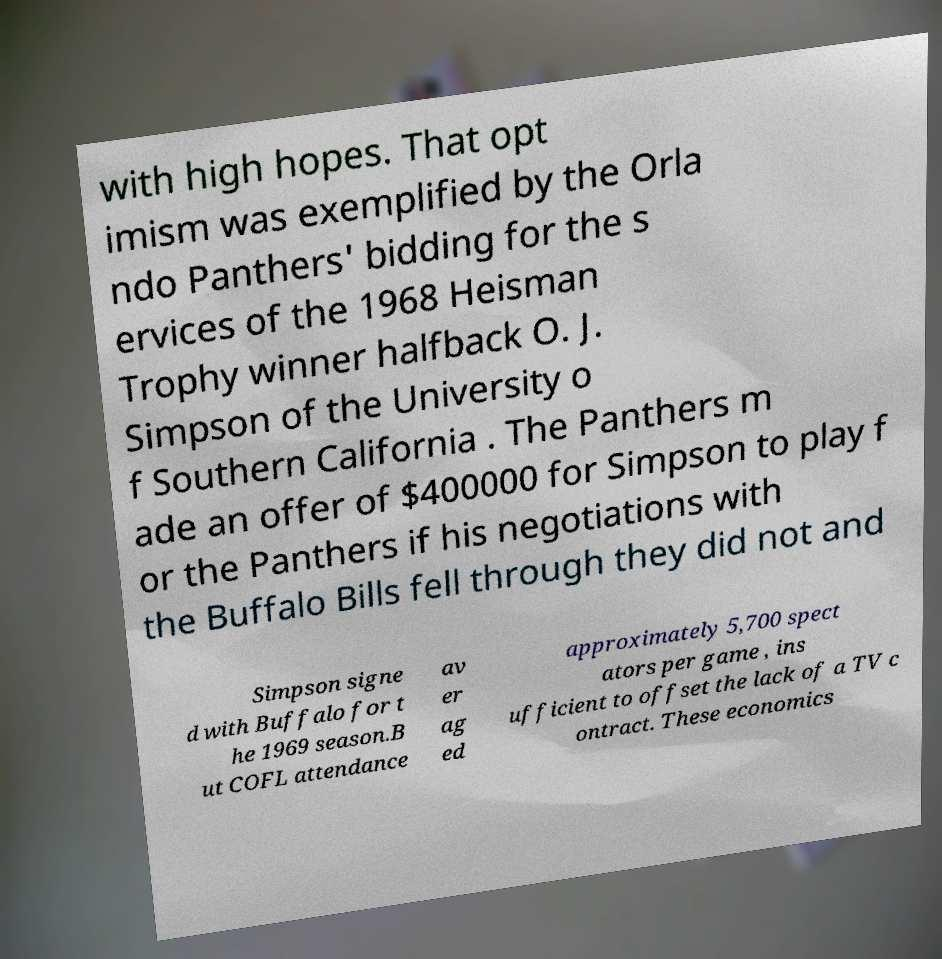There's text embedded in this image that I need extracted. Can you transcribe it verbatim? with high hopes. That opt imism was exemplified by the Orla ndo Panthers' bidding for the s ervices of the 1968 Heisman Trophy winner halfback O. J. Simpson of the University o f Southern California . The Panthers m ade an offer of $400000 for Simpson to play f or the Panthers if his negotiations with the Buffalo Bills fell through they did not and Simpson signe d with Buffalo for t he 1969 season.B ut COFL attendance av er ag ed approximately 5,700 spect ators per game , ins ufficient to offset the lack of a TV c ontract. These economics 